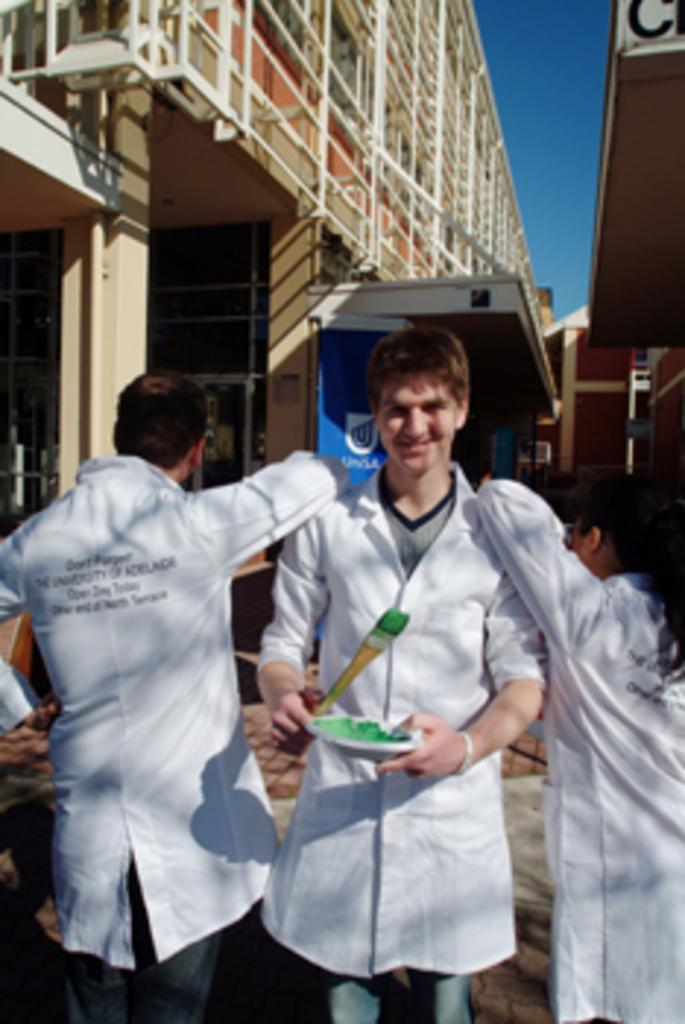How many people are in the image? There are three people in the image. What are the people wearing? The people are wearing white color jackets. Where are the people positioned in the image? The people are standing in the front. What is one object visible in the image? There is a street lamp in the image. What type of structures can be seen in the image? There are buildings in the image. What additional item is present in the image? There is a banner in the image. What part of the natural environment is visible in the image? The sky is visible in the image. How many feet does the son have in the image? There is no son present in the image, so it is not possible to determine the number of feet he might have. 